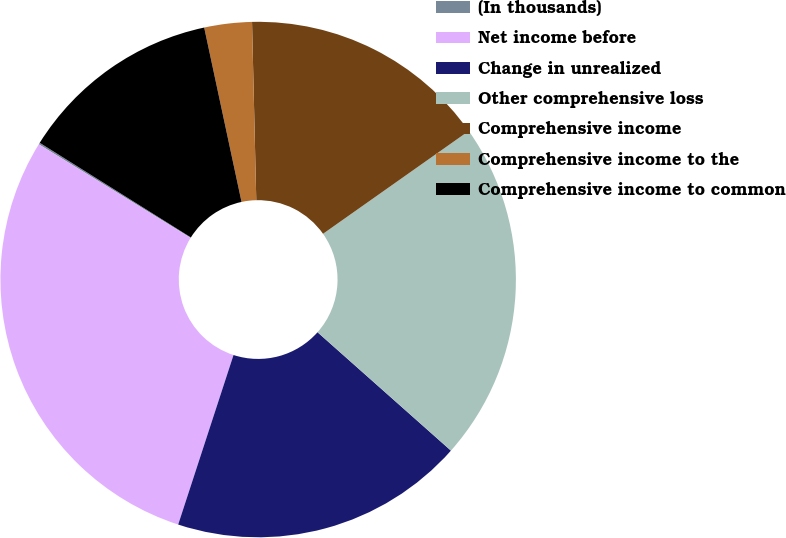<chart> <loc_0><loc_0><loc_500><loc_500><pie_chart><fcel>(In thousands)<fcel>Net income before<fcel>Change in unrealized<fcel>Other comprehensive loss<fcel>Comprehensive income<fcel>Comprehensive income to the<fcel>Comprehensive income to common<nl><fcel>0.11%<fcel>28.77%<fcel>18.47%<fcel>21.33%<fcel>15.6%<fcel>2.98%<fcel>12.74%<nl></chart> 